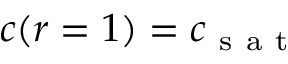<formula> <loc_0><loc_0><loc_500><loc_500>c ( r = 1 ) = c _ { s a t }</formula> 